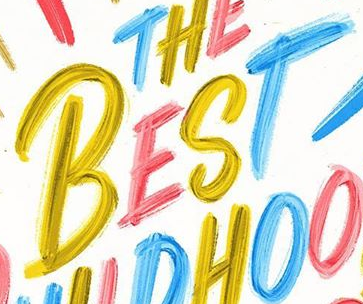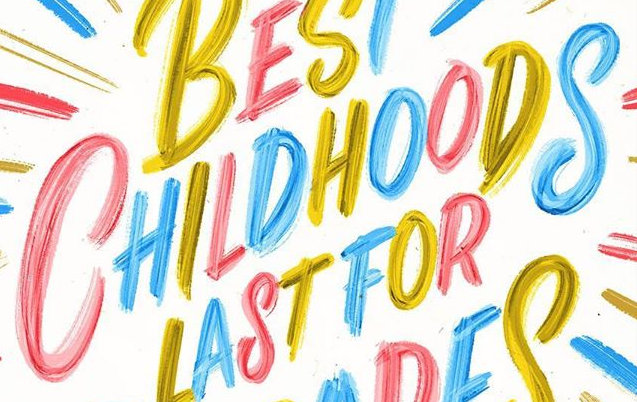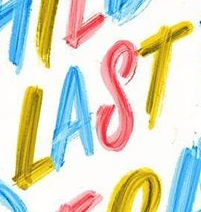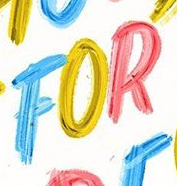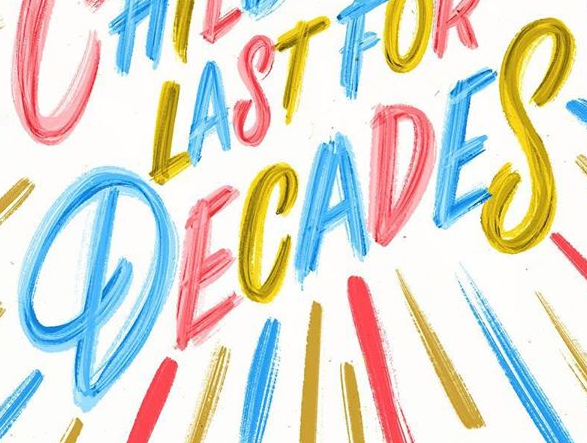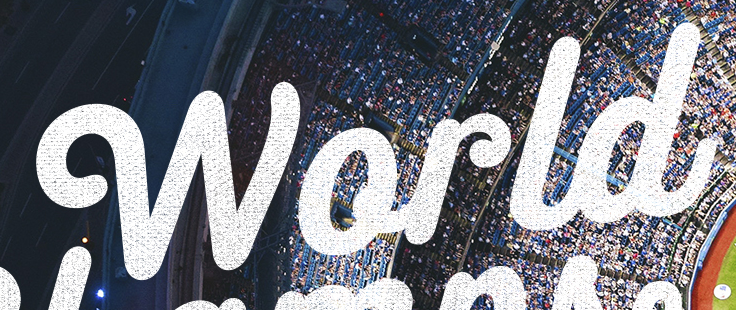Identify the words shown in these images in order, separated by a semicolon. BEST; CHILDHOODS; LAST; FOR; DECADES; World 